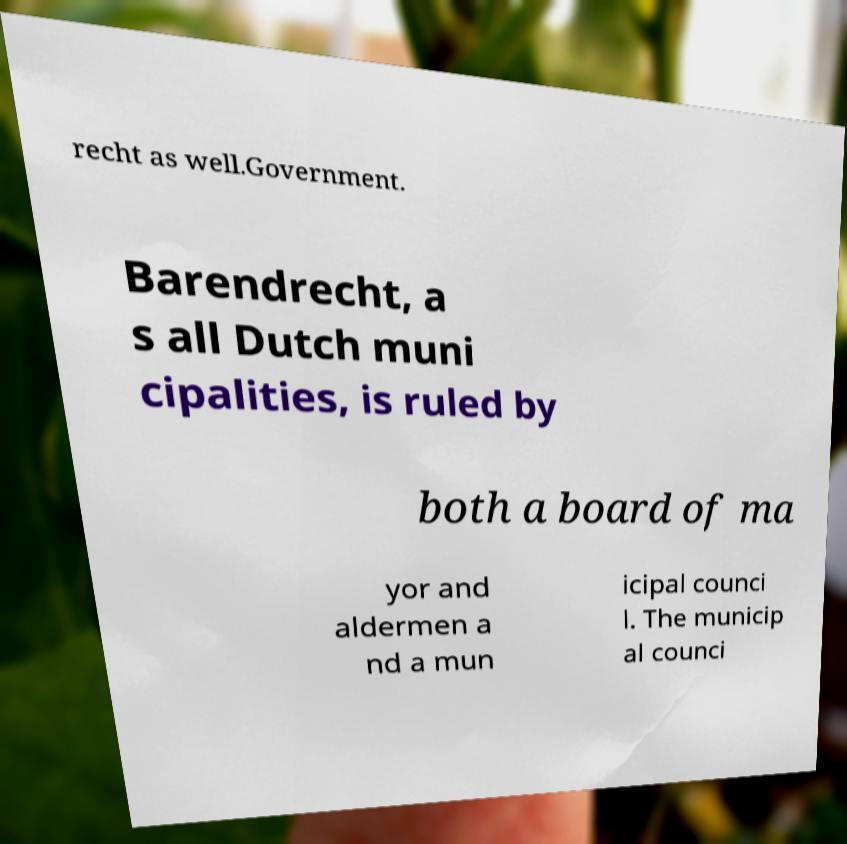What messages or text are displayed in this image? I need them in a readable, typed format. recht as well.Government. Barendrecht, a s all Dutch muni cipalities, is ruled by both a board of ma yor and aldermen a nd a mun icipal counci l. The municip al counci 